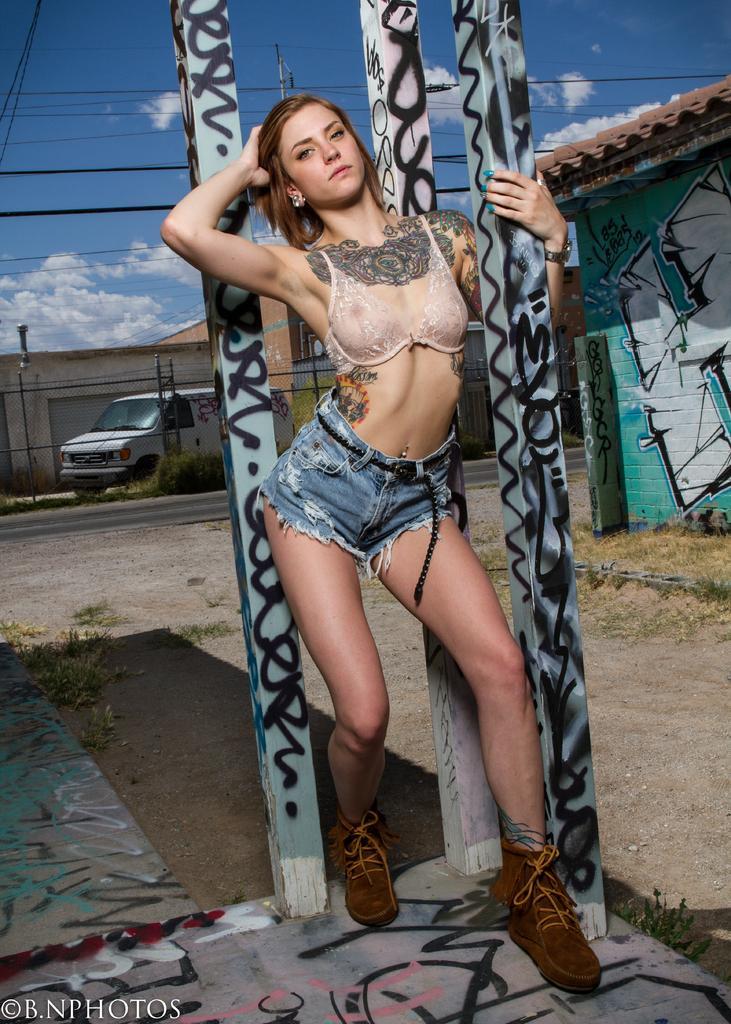Can you describe this image briefly? In this picture there is a woman standing and holding an wooden object in her hand and there are two other wooden objects behind her and there is a vehicle and buildings in the background and there is something written in the left bottom corner. 